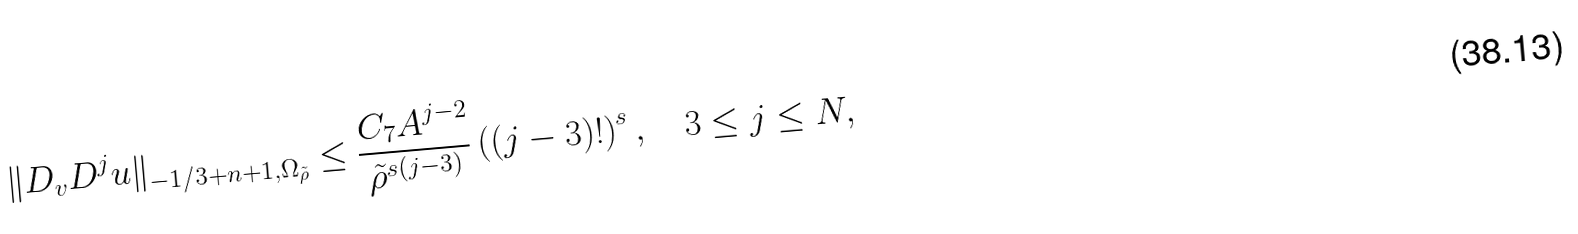<formula> <loc_0><loc_0><loc_500><loc_500>\| D _ { v } D ^ { j } u \| _ { - 1 / 3 + n + 1 , \Omega _ { \tilde { \rho } } } \leq \frac { C _ { 7 } A ^ { j - 2 } } { \tilde { \rho } ^ { s ( j - 3 ) } } \left ( ( j - 3 ) ! \right ) ^ { s } , \quad 3 \leq j \leq N ,</formula> 